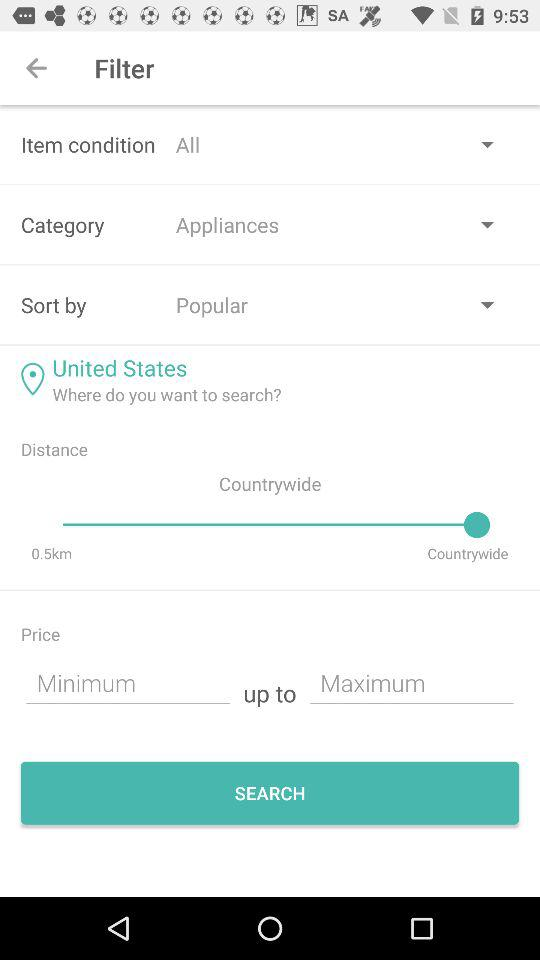What option is selected in "item condition"? The option is "All". 